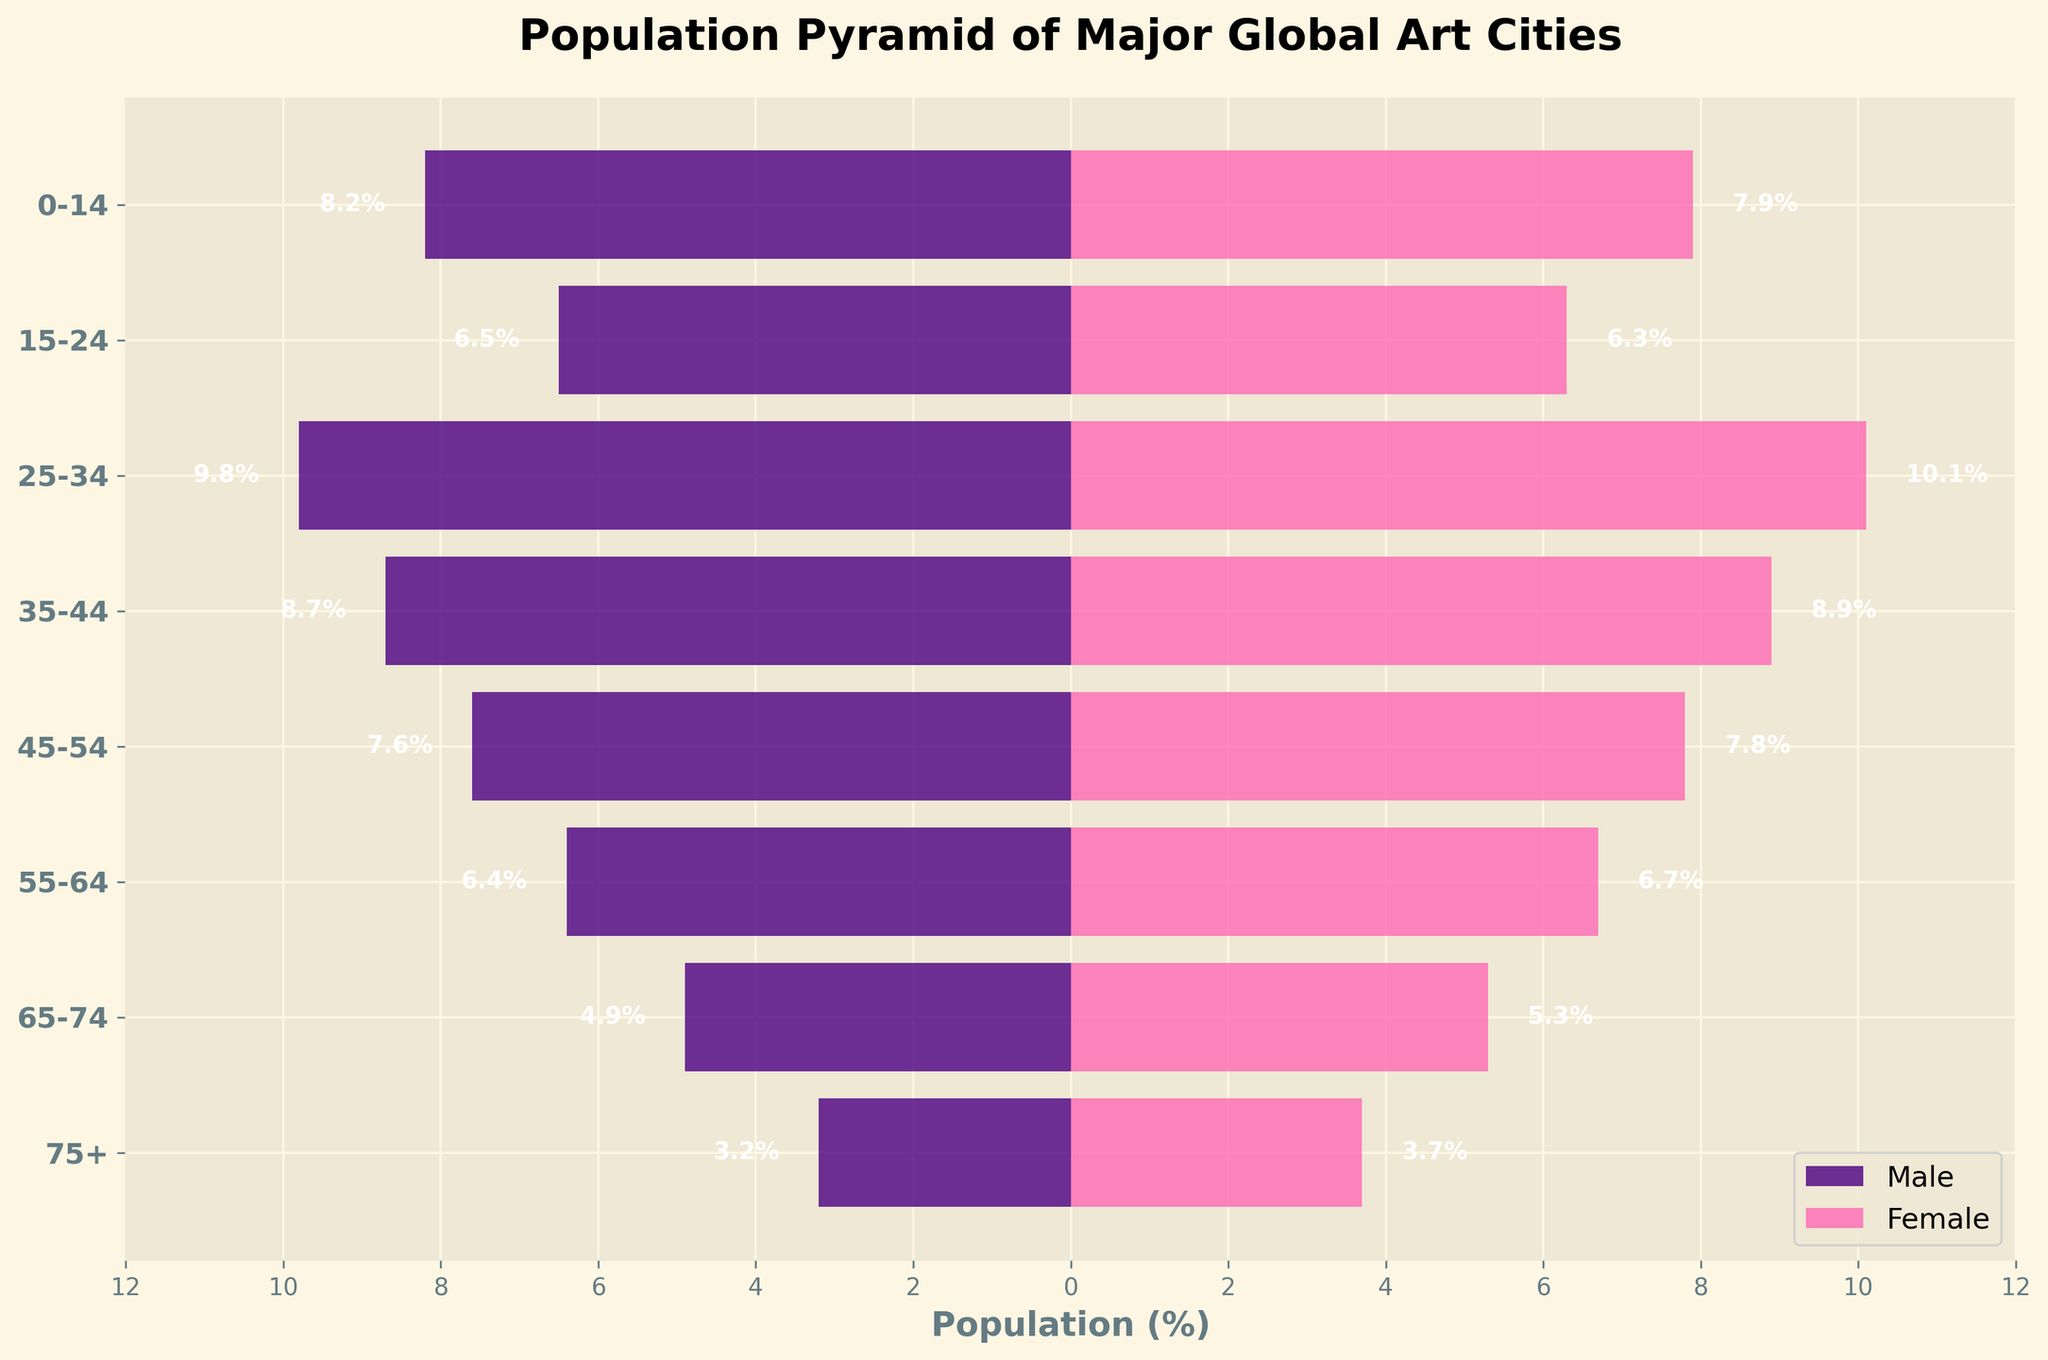What is the title of the plot? The title is usually placed at the top center of the plot and describes what the figure represents.
Answer: Population Pyramid of Major Global Art Cities What colors are used to represent males and females? The colors for male and female groups can be distinguished by their appearance in the bars.
Answer: Males are Indigo and females are Pink What age group has the highest female population percentage? To answer this, look for the longest pink bar in the plot with the highest value among the female population bars.
Answer: 25-34 What is the male population percentage for the age group 65-74? Locate the indigo bar for the age group 65-74 and read the value at its end.
Answer: 4.9% Is the percentage of females in the 15-24 age group higher or lower than that of males? Compare the lengths of the pink and indigo bars for the 15-24 age group.
Answer: Lower What is the total percentage of the population aged above 55 (both genders combined)? Add the percentages for males and females across the age groups 55-64, 65-74, and 75+. Perform this calculation: (6.4 + 6.7) + (4.9 + 5.3) + (3.2 + 3.7) = 30.2
Answer: 30.2% Which age group shows a higher male population percentage than females? Identify any age group where the indigo bar extends further to the left than the pink bar extends to the right.
Answer: 0-14 What percentage of males is in the 75+ age group? Locate the indigo bar corresponding to the 75+ age group and read the value.
Answer: 3.2% How does the male percentage in the 25-34 age group compare to that in the 55-64 age group? Compare the lengths of the indigo bars for the 25-34 and 55-64 age groups to determine which is longer.
Answer: 25-34 has higher What is the difference in population percentage between males and females in the 45-54 age group? Find the values for males and females in the 45-54 age group and calculate the absolute difference:
Answer: 0.2% 